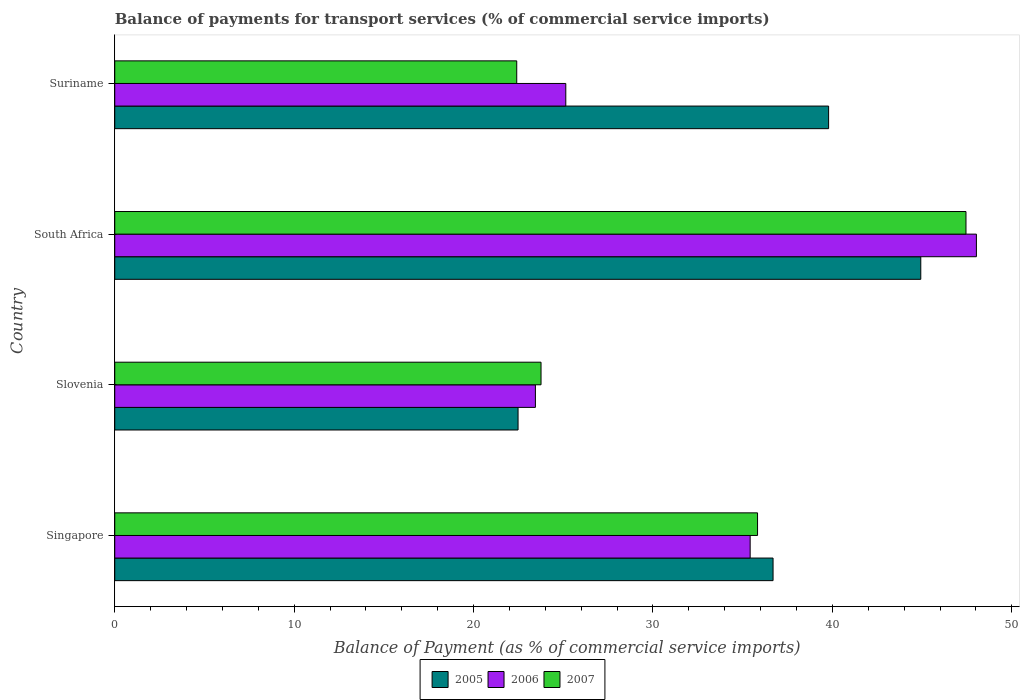How many different coloured bars are there?
Provide a succinct answer. 3. How many groups of bars are there?
Provide a short and direct response. 4. How many bars are there on the 1st tick from the top?
Provide a short and direct response. 3. What is the label of the 2nd group of bars from the top?
Your response must be concise. South Africa. In how many cases, is the number of bars for a given country not equal to the number of legend labels?
Offer a very short reply. 0. What is the balance of payments for transport services in 2006 in Suriname?
Provide a short and direct response. 25.14. Across all countries, what is the maximum balance of payments for transport services in 2005?
Your answer should be compact. 44.93. Across all countries, what is the minimum balance of payments for transport services in 2006?
Provide a succinct answer. 23.45. In which country was the balance of payments for transport services in 2005 maximum?
Keep it short and to the point. South Africa. In which country was the balance of payments for transport services in 2006 minimum?
Provide a succinct answer. Slovenia. What is the total balance of payments for transport services in 2005 in the graph?
Offer a very short reply. 143.89. What is the difference between the balance of payments for transport services in 2006 in Singapore and that in South Africa?
Give a very brief answer. -12.61. What is the difference between the balance of payments for transport services in 2007 in South Africa and the balance of payments for transport services in 2006 in Suriname?
Your response must be concise. 22.31. What is the average balance of payments for transport services in 2007 per country?
Make the answer very short. 32.36. What is the difference between the balance of payments for transport services in 2006 and balance of payments for transport services in 2007 in Singapore?
Your response must be concise. -0.41. What is the ratio of the balance of payments for transport services in 2006 in Slovenia to that in Suriname?
Your answer should be very brief. 0.93. Is the balance of payments for transport services in 2007 in Singapore less than that in South Africa?
Your answer should be compact. Yes. What is the difference between the highest and the second highest balance of payments for transport services in 2006?
Provide a succinct answer. 12.61. What is the difference between the highest and the lowest balance of payments for transport services in 2006?
Provide a succinct answer. 24.58. In how many countries, is the balance of payments for transport services in 2006 greater than the average balance of payments for transport services in 2006 taken over all countries?
Make the answer very short. 2. Is the sum of the balance of payments for transport services in 2006 in Slovenia and South Africa greater than the maximum balance of payments for transport services in 2007 across all countries?
Provide a short and direct response. Yes. What does the 2nd bar from the bottom in Singapore represents?
Give a very brief answer. 2006. Is it the case that in every country, the sum of the balance of payments for transport services in 2006 and balance of payments for transport services in 2007 is greater than the balance of payments for transport services in 2005?
Offer a very short reply. Yes. How many bars are there?
Keep it short and to the point. 12. How many countries are there in the graph?
Provide a succinct answer. 4. Are the values on the major ticks of X-axis written in scientific E-notation?
Provide a short and direct response. No. Does the graph contain grids?
Provide a succinct answer. No. What is the title of the graph?
Offer a very short reply. Balance of payments for transport services (% of commercial service imports). What is the label or title of the X-axis?
Ensure brevity in your answer.  Balance of Payment (as % of commercial service imports). What is the label or title of the Y-axis?
Make the answer very short. Country. What is the Balance of Payment (as % of commercial service imports) in 2005 in Singapore?
Make the answer very short. 36.69. What is the Balance of Payment (as % of commercial service imports) of 2006 in Singapore?
Your answer should be very brief. 35.42. What is the Balance of Payment (as % of commercial service imports) of 2007 in Singapore?
Provide a succinct answer. 35.83. What is the Balance of Payment (as % of commercial service imports) in 2005 in Slovenia?
Provide a succinct answer. 22.48. What is the Balance of Payment (as % of commercial service imports) in 2006 in Slovenia?
Make the answer very short. 23.45. What is the Balance of Payment (as % of commercial service imports) of 2007 in Slovenia?
Give a very brief answer. 23.76. What is the Balance of Payment (as % of commercial service imports) in 2005 in South Africa?
Make the answer very short. 44.93. What is the Balance of Payment (as % of commercial service imports) in 2006 in South Africa?
Your answer should be very brief. 48.03. What is the Balance of Payment (as % of commercial service imports) in 2007 in South Africa?
Your response must be concise. 47.45. What is the Balance of Payment (as % of commercial service imports) of 2005 in Suriname?
Provide a short and direct response. 39.79. What is the Balance of Payment (as % of commercial service imports) of 2006 in Suriname?
Provide a succinct answer. 25.14. What is the Balance of Payment (as % of commercial service imports) of 2007 in Suriname?
Ensure brevity in your answer.  22.41. Across all countries, what is the maximum Balance of Payment (as % of commercial service imports) in 2005?
Your response must be concise. 44.93. Across all countries, what is the maximum Balance of Payment (as % of commercial service imports) in 2006?
Give a very brief answer. 48.03. Across all countries, what is the maximum Balance of Payment (as % of commercial service imports) in 2007?
Give a very brief answer. 47.45. Across all countries, what is the minimum Balance of Payment (as % of commercial service imports) in 2005?
Give a very brief answer. 22.48. Across all countries, what is the minimum Balance of Payment (as % of commercial service imports) of 2006?
Give a very brief answer. 23.45. Across all countries, what is the minimum Balance of Payment (as % of commercial service imports) of 2007?
Make the answer very short. 22.41. What is the total Balance of Payment (as % of commercial service imports) of 2005 in the graph?
Your answer should be very brief. 143.89. What is the total Balance of Payment (as % of commercial service imports) in 2006 in the graph?
Offer a very short reply. 132.04. What is the total Balance of Payment (as % of commercial service imports) of 2007 in the graph?
Keep it short and to the point. 129.45. What is the difference between the Balance of Payment (as % of commercial service imports) in 2005 in Singapore and that in Slovenia?
Keep it short and to the point. 14.21. What is the difference between the Balance of Payment (as % of commercial service imports) in 2006 in Singapore and that in Slovenia?
Offer a very short reply. 11.97. What is the difference between the Balance of Payment (as % of commercial service imports) of 2007 in Singapore and that in Slovenia?
Make the answer very short. 12.07. What is the difference between the Balance of Payment (as % of commercial service imports) in 2005 in Singapore and that in South Africa?
Offer a terse response. -8.23. What is the difference between the Balance of Payment (as % of commercial service imports) of 2006 in Singapore and that in South Africa?
Offer a very short reply. -12.61. What is the difference between the Balance of Payment (as % of commercial service imports) in 2007 in Singapore and that in South Africa?
Make the answer very short. -11.62. What is the difference between the Balance of Payment (as % of commercial service imports) of 2005 in Singapore and that in Suriname?
Provide a short and direct response. -3.1. What is the difference between the Balance of Payment (as % of commercial service imports) of 2006 in Singapore and that in Suriname?
Your response must be concise. 10.28. What is the difference between the Balance of Payment (as % of commercial service imports) of 2007 in Singapore and that in Suriname?
Ensure brevity in your answer.  13.42. What is the difference between the Balance of Payment (as % of commercial service imports) of 2005 in Slovenia and that in South Africa?
Offer a terse response. -22.45. What is the difference between the Balance of Payment (as % of commercial service imports) in 2006 in Slovenia and that in South Africa?
Your answer should be very brief. -24.58. What is the difference between the Balance of Payment (as % of commercial service imports) of 2007 in Slovenia and that in South Africa?
Your answer should be very brief. -23.69. What is the difference between the Balance of Payment (as % of commercial service imports) in 2005 in Slovenia and that in Suriname?
Provide a short and direct response. -17.31. What is the difference between the Balance of Payment (as % of commercial service imports) in 2006 in Slovenia and that in Suriname?
Your response must be concise. -1.69. What is the difference between the Balance of Payment (as % of commercial service imports) of 2007 in Slovenia and that in Suriname?
Offer a terse response. 1.35. What is the difference between the Balance of Payment (as % of commercial service imports) in 2005 in South Africa and that in Suriname?
Your answer should be very brief. 5.14. What is the difference between the Balance of Payment (as % of commercial service imports) of 2006 in South Africa and that in Suriname?
Offer a terse response. 22.89. What is the difference between the Balance of Payment (as % of commercial service imports) in 2007 in South Africa and that in Suriname?
Offer a very short reply. 25.04. What is the difference between the Balance of Payment (as % of commercial service imports) of 2005 in Singapore and the Balance of Payment (as % of commercial service imports) of 2006 in Slovenia?
Your response must be concise. 13.25. What is the difference between the Balance of Payment (as % of commercial service imports) in 2005 in Singapore and the Balance of Payment (as % of commercial service imports) in 2007 in Slovenia?
Provide a short and direct response. 12.93. What is the difference between the Balance of Payment (as % of commercial service imports) of 2006 in Singapore and the Balance of Payment (as % of commercial service imports) of 2007 in Slovenia?
Keep it short and to the point. 11.66. What is the difference between the Balance of Payment (as % of commercial service imports) in 2005 in Singapore and the Balance of Payment (as % of commercial service imports) in 2006 in South Africa?
Give a very brief answer. -11.34. What is the difference between the Balance of Payment (as % of commercial service imports) in 2005 in Singapore and the Balance of Payment (as % of commercial service imports) in 2007 in South Africa?
Provide a short and direct response. -10.75. What is the difference between the Balance of Payment (as % of commercial service imports) of 2006 in Singapore and the Balance of Payment (as % of commercial service imports) of 2007 in South Africa?
Offer a very short reply. -12.03. What is the difference between the Balance of Payment (as % of commercial service imports) in 2005 in Singapore and the Balance of Payment (as % of commercial service imports) in 2006 in Suriname?
Offer a very short reply. 11.55. What is the difference between the Balance of Payment (as % of commercial service imports) in 2005 in Singapore and the Balance of Payment (as % of commercial service imports) in 2007 in Suriname?
Your answer should be compact. 14.29. What is the difference between the Balance of Payment (as % of commercial service imports) in 2006 in Singapore and the Balance of Payment (as % of commercial service imports) in 2007 in Suriname?
Give a very brief answer. 13.01. What is the difference between the Balance of Payment (as % of commercial service imports) of 2005 in Slovenia and the Balance of Payment (as % of commercial service imports) of 2006 in South Africa?
Offer a terse response. -25.55. What is the difference between the Balance of Payment (as % of commercial service imports) in 2005 in Slovenia and the Balance of Payment (as % of commercial service imports) in 2007 in South Africa?
Provide a short and direct response. -24.97. What is the difference between the Balance of Payment (as % of commercial service imports) in 2006 in Slovenia and the Balance of Payment (as % of commercial service imports) in 2007 in South Africa?
Offer a very short reply. -24. What is the difference between the Balance of Payment (as % of commercial service imports) in 2005 in Slovenia and the Balance of Payment (as % of commercial service imports) in 2006 in Suriname?
Provide a short and direct response. -2.66. What is the difference between the Balance of Payment (as % of commercial service imports) in 2005 in Slovenia and the Balance of Payment (as % of commercial service imports) in 2007 in Suriname?
Offer a terse response. 0.07. What is the difference between the Balance of Payment (as % of commercial service imports) of 2006 in Slovenia and the Balance of Payment (as % of commercial service imports) of 2007 in Suriname?
Ensure brevity in your answer.  1.04. What is the difference between the Balance of Payment (as % of commercial service imports) in 2005 in South Africa and the Balance of Payment (as % of commercial service imports) in 2006 in Suriname?
Offer a terse response. 19.79. What is the difference between the Balance of Payment (as % of commercial service imports) of 2005 in South Africa and the Balance of Payment (as % of commercial service imports) of 2007 in Suriname?
Your answer should be compact. 22.52. What is the difference between the Balance of Payment (as % of commercial service imports) in 2006 in South Africa and the Balance of Payment (as % of commercial service imports) in 2007 in Suriname?
Give a very brief answer. 25.62. What is the average Balance of Payment (as % of commercial service imports) in 2005 per country?
Your answer should be compact. 35.97. What is the average Balance of Payment (as % of commercial service imports) in 2006 per country?
Offer a very short reply. 33.01. What is the average Balance of Payment (as % of commercial service imports) of 2007 per country?
Give a very brief answer. 32.36. What is the difference between the Balance of Payment (as % of commercial service imports) of 2005 and Balance of Payment (as % of commercial service imports) of 2006 in Singapore?
Your response must be concise. 1.28. What is the difference between the Balance of Payment (as % of commercial service imports) in 2005 and Balance of Payment (as % of commercial service imports) in 2007 in Singapore?
Offer a very short reply. 0.86. What is the difference between the Balance of Payment (as % of commercial service imports) in 2006 and Balance of Payment (as % of commercial service imports) in 2007 in Singapore?
Offer a very short reply. -0.41. What is the difference between the Balance of Payment (as % of commercial service imports) of 2005 and Balance of Payment (as % of commercial service imports) of 2006 in Slovenia?
Ensure brevity in your answer.  -0.97. What is the difference between the Balance of Payment (as % of commercial service imports) of 2005 and Balance of Payment (as % of commercial service imports) of 2007 in Slovenia?
Keep it short and to the point. -1.28. What is the difference between the Balance of Payment (as % of commercial service imports) of 2006 and Balance of Payment (as % of commercial service imports) of 2007 in Slovenia?
Make the answer very short. -0.31. What is the difference between the Balance of Payment (as % of commercial service imports) of 2005 and Balance of Payment (as % of commercial service imports) of 2006 in South Africa?
Make the answer very short. -3.1. What is the difference between the Balance of Payment (as % of commercial service imports) in 2005 and Balance of Payment (as % of commercial service imports) in 2007 in South Africa?
Offer a very short reply. -2.52. What is the difference between the Balance of Payment (as % of commercial service imports) of 2006 and Balance of Payment (as % of commercial service imports) of 2007 in South Africa?
Ensure brevity in your answer.  0.58. What is the difference between the Balance of Payment (as % of commercial service imports) of 2005 and Balance of Payment (as % of commercial service imports) of 2006 in Suriname?
Offer a very short reply. 14.65. What is the difference between the Balance of Payment (as % of commercial service imports) of 2005 and Balance of Payment (as % of commercial service imports) of 2007 in Suriname?
Your answer should be very brief. 17.38. What is the difference between the Balance of Payment (as % of commercial service imports) in 2006 and Balance of Payment (as % of commercial service imports) in 2007 in Suriname?
Offer a very short reply. 2.73. What is the ratio of the Balance of Payment (as % of commercial service imports) in 2005 in Singapore to that in Slovenia?
Make the answer very short. 1.63. What is the ratio of the Balance of Payment (as % of commercial service imports) of 2006 in Singapore to that in Slovenia?
Your answer should be very brief. 1.51. What is the ratio of the Balance of Payment (as % of commercial service imports) in 2007 in Singapore to that in Slovenia?
Ensure brevity in your answer.  1.51. What is the ratio of the Balance of Payment (as % of commercial service imports) in 2005 in Singapore to that in South Africa?
Your answer should be very brief. 0.82. What is the ratio of the Balance of Payment (as % of commercial service imports) of 2006 in Singapore to that in South Africa?
Provide a short and direct response. 0.74. What is the ratio of the Balance of Payment (as % of commercial service imports) of 2007 in Singapore to that in South Africa?
Your answer should be compact. 0.76. What is the ratio of the Balance of Payment (as % of commercial service imports) of 2005 in Singapore to that in Suriname?
Provide a short and direct response. 0.92. What is the ratio of the Balance of Payment (as % of commercial service imports) in 2006 in Singapore to that in Suriname?
Your answer should be compact. 1.41. What is the ratio of the Balance of Payment (as % of commercial service imports) in 2007 in Singapore to that in Suriname?
Your answer should be compact. 1.6. What is the ratio of the Balance of Payment (as % of commercial service imports) of 2005 in Slovenia to that in South Africa?
Offer a very short reply. 0.5. What is the ratio of the Balance of Payment (as % of commercial service imports) in 2006 in Slovenia to that in South Africa?
Provide a succinct answer. 0.49. What is the ratio of the Balance of Payment (as % of commercial service imports) in 2007 in Slovenia to that in South Africa?
Offer a very short reply. 0.5. What is the ratio of the Balance of Payment (as % of commercial service imports) of 2005 in Slovenia to that in Suriname?
Offer a very short reply. 0.56. What is the ratio of the Balance of Payment (as % of commercial service imports) in 2006 in Slovenia to that in Suriname?
Offer a terse response. 0.93. What is the ratio of the Balance of Payment (as % of commercial service imports) in 2007 in Slovenia to that in Suriname?
Provide a succinct answer. 1.06. What is the ratio of the Balance of Payment (as % of commercial service imports) of 2005 in South Africa to that in Suriname?
Offer a terse response. 1.13. What is the ratio of the Balance of Payment (as % of commercial service imports) in 2006 in South Africa to that in Suriname?
Your response must be concise. 1.91. What is the ratio of the Balance of Payment (as % of commercial service imports) in 2007 in South Africa to that in Suriname?
Offer a terse response. 2.12. What is the difference between the highest and the second highest Balance of Payment (as % of commercial service imports) in 2005?
Your response must be concise. 5.14. What is the difference between the highest and the second highest Balance of Payment (as % of commercial service imports) of 2006?
Provide a short and direct response. 12.61. What is the difference between the highest and the second highest Balance of Payment (as % of commercial service imports) of 2007?
Offer a very short reply. 11.62. What is the difference between the highest and the lowest Balance of Payment (as % of commercial service imports) of 2005?
Offer a very short reply. 22.45. What is the difference between the highest and the lowest Balance of Payment (as % of commercial service imports) in 2006?
Ensure brevity in your answer.  24.58. What is the difference between the highest and the lowest Balance of Payment (as % of commercial service imports) in 2007?
Your answer should be very brief. 25.04. 